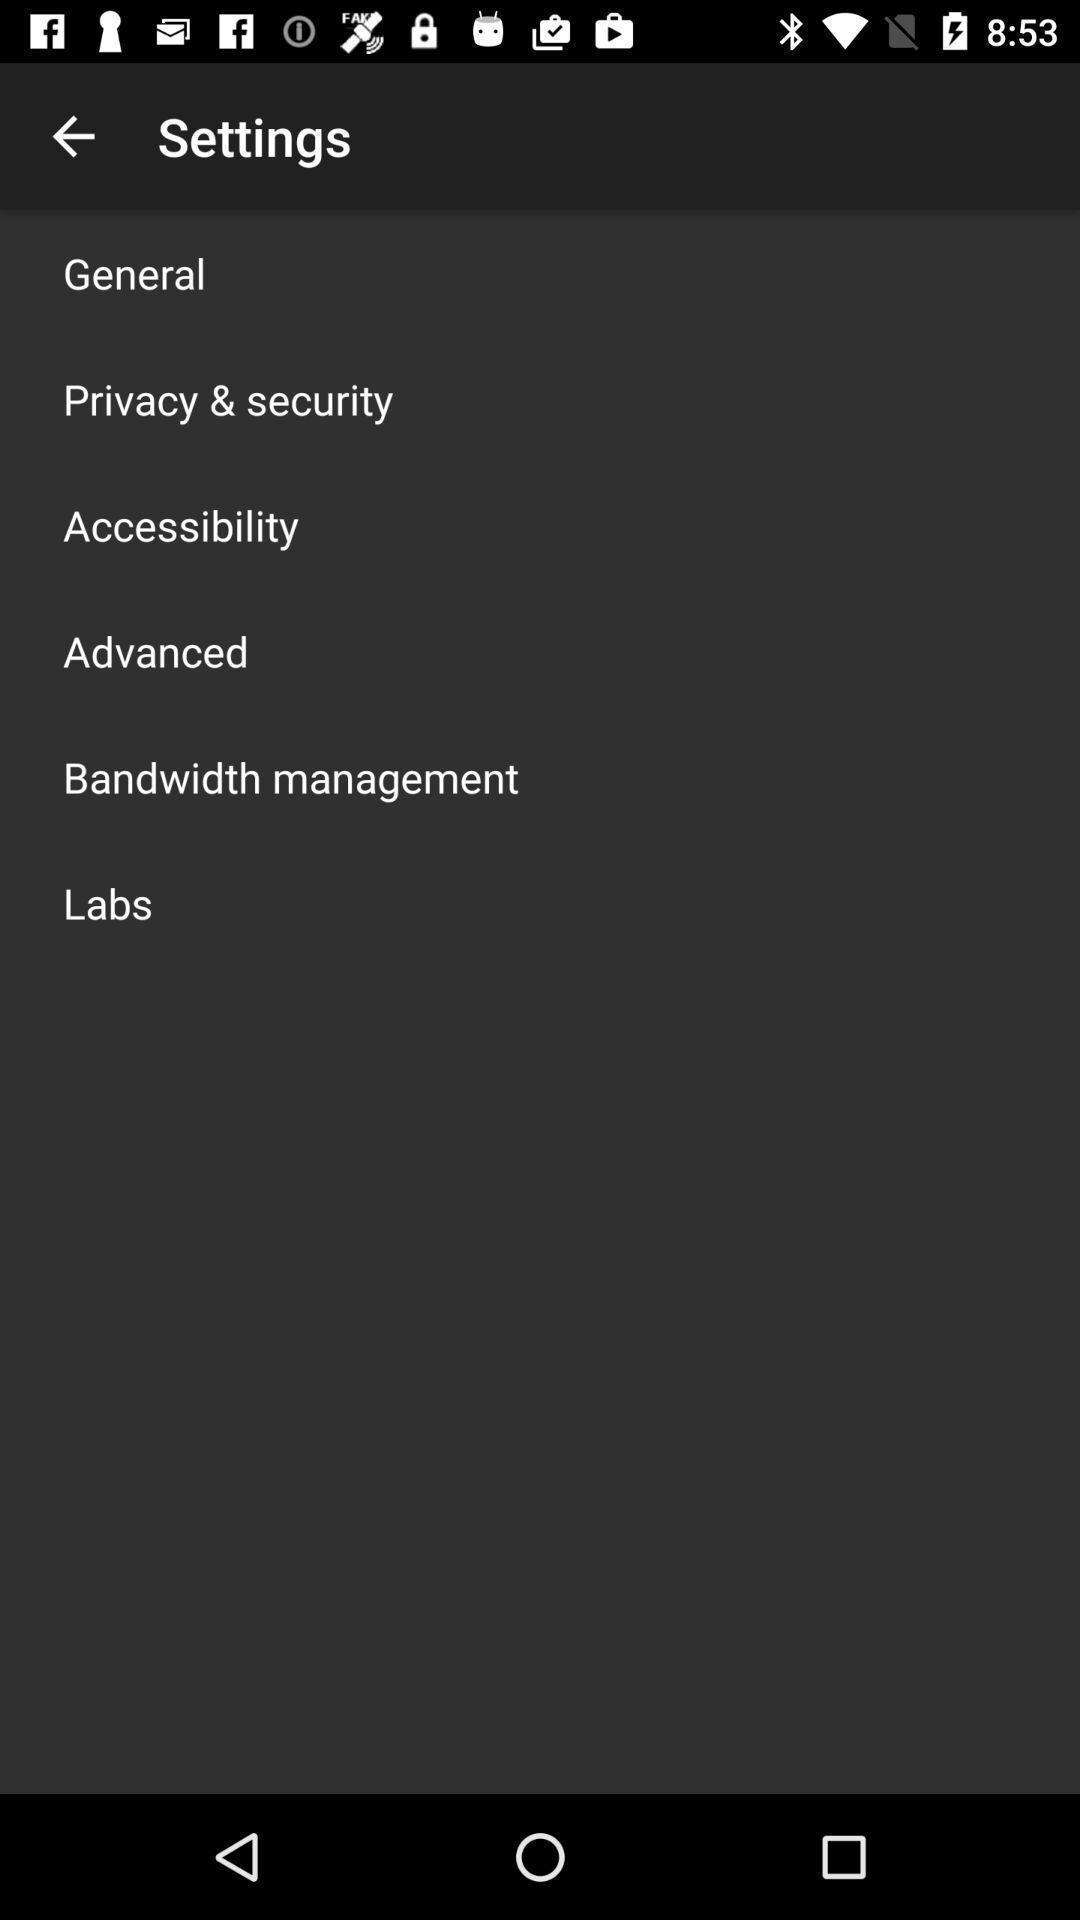Describe this image in words. Page showing settings options of app. 